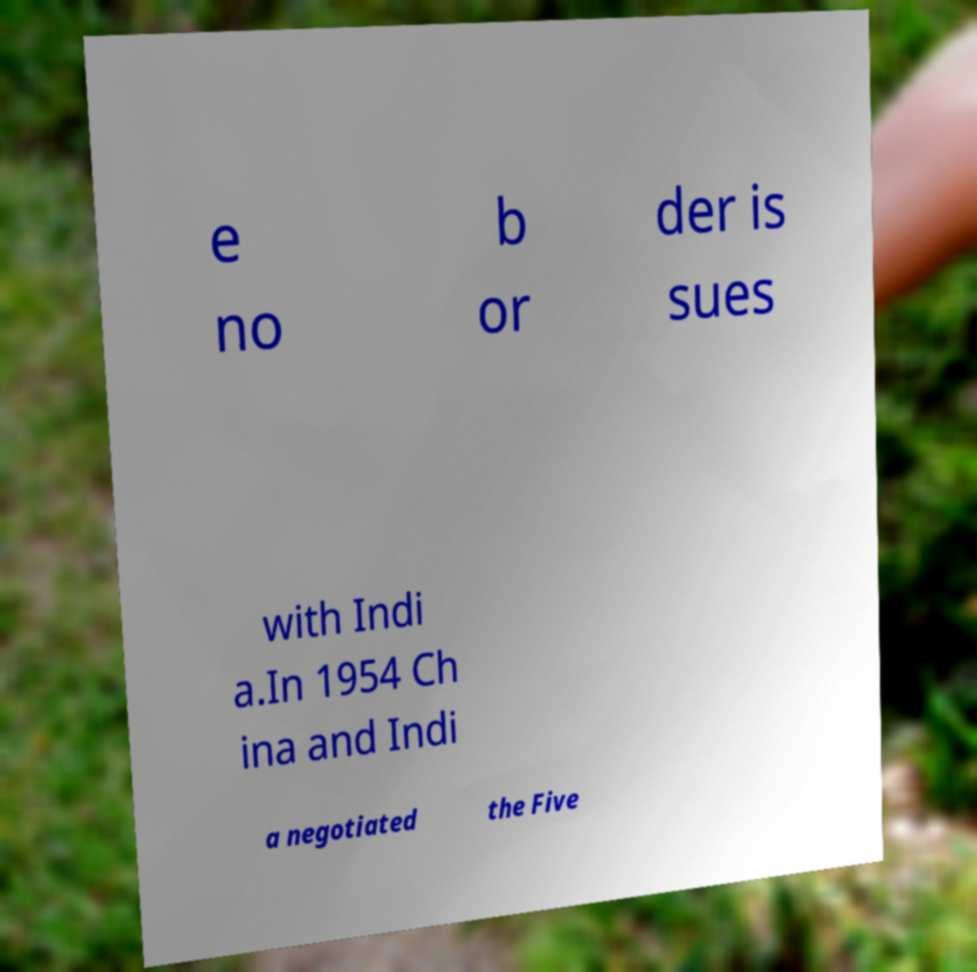There's text embedded in this image that I need extracted. Can you transcribe it verbatim? e no b or der is sues with Indi a.In 1954 Ch ina and Indi a negotiated the Five 